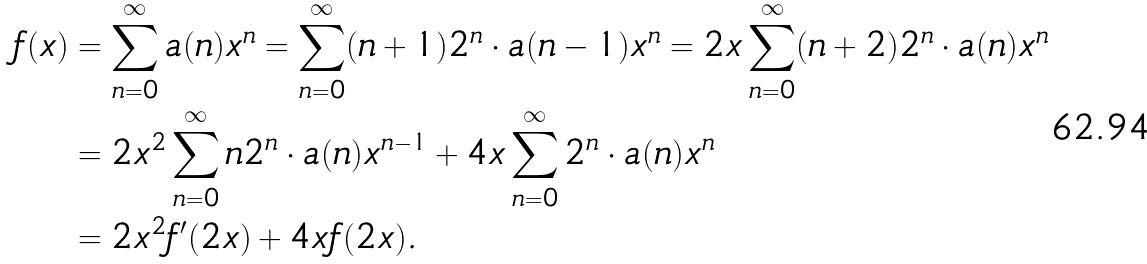Convert formula to latex. <formula><loc_0><loc_0><loc_500><loc_500>f ( x ) & = \sum _ { n = 0 } ^ { \infty } a ( n ) x ^ { n } = \sum _ { n = 0 } ^ { \infty } ( n + 1 ) 2 ^ { n } \cdot a ( n - 1 ) x ^ { n } = 2 x \sum _ { n = 0 } ^ { \infty } ( n + 2 ) 2 ^ { n } \cdot a ( n ) x ^ { n } \\ & = 2 x ^ { 2 } \sum _ { n = 0 } ^ { \infty } n 2 ^ { n } \cdot a ( n ) x ^ { n - 1 } + 4 x \sum _ { n = 0 } ^ { \infty } 2 ^ { n } \cdot a ( n ) x ^ { n } \\ & = 2 x ^ { 2 } f ^ { \prime } ( 2 x ) + 4 x f ( 2 x ) .</formula> 